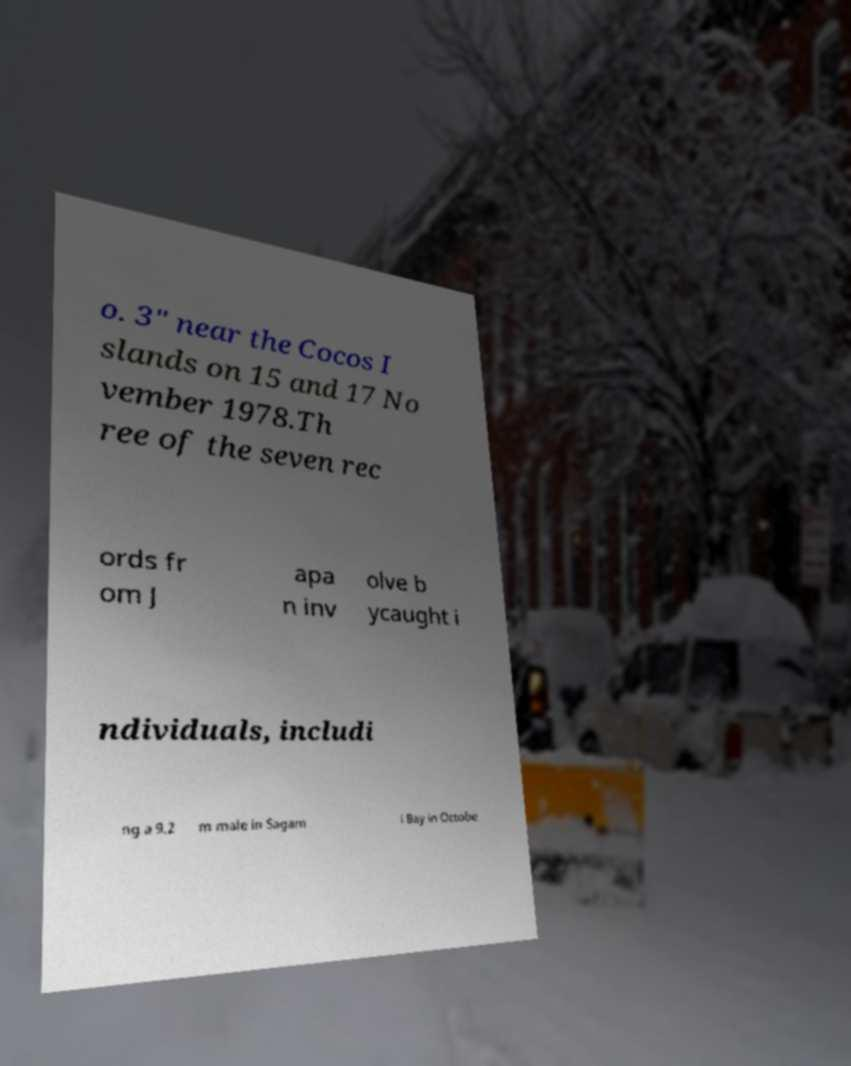Can you read and provide the text displayed in the image?This photo seems to have some interesting text. Can you extract and type it out for me? o. 3" near the Cocos I slands on 15 and 17 No vember 1978.Th ree of the seven rec ords fr om J apa n inv olve b ycaught i ndividuals, includi ng a 9.2 m male in Sagam i Bay in Octobe 